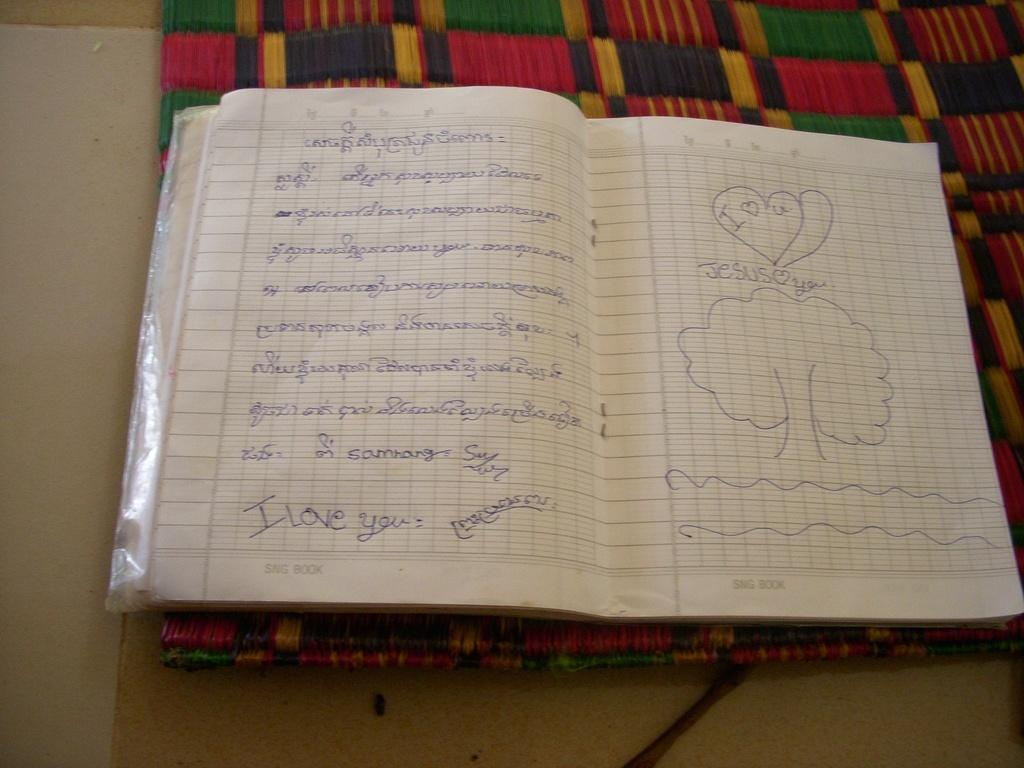What is the main object in the image? There is an opened notebook in the image. What can be seen on the notebook? There is text written on the notebook. Where is the notebook placed? The notebook is placed on a mat. What type of plant is growing inside the notebook in the image? There is no plant growing inside the notebook in the image. 